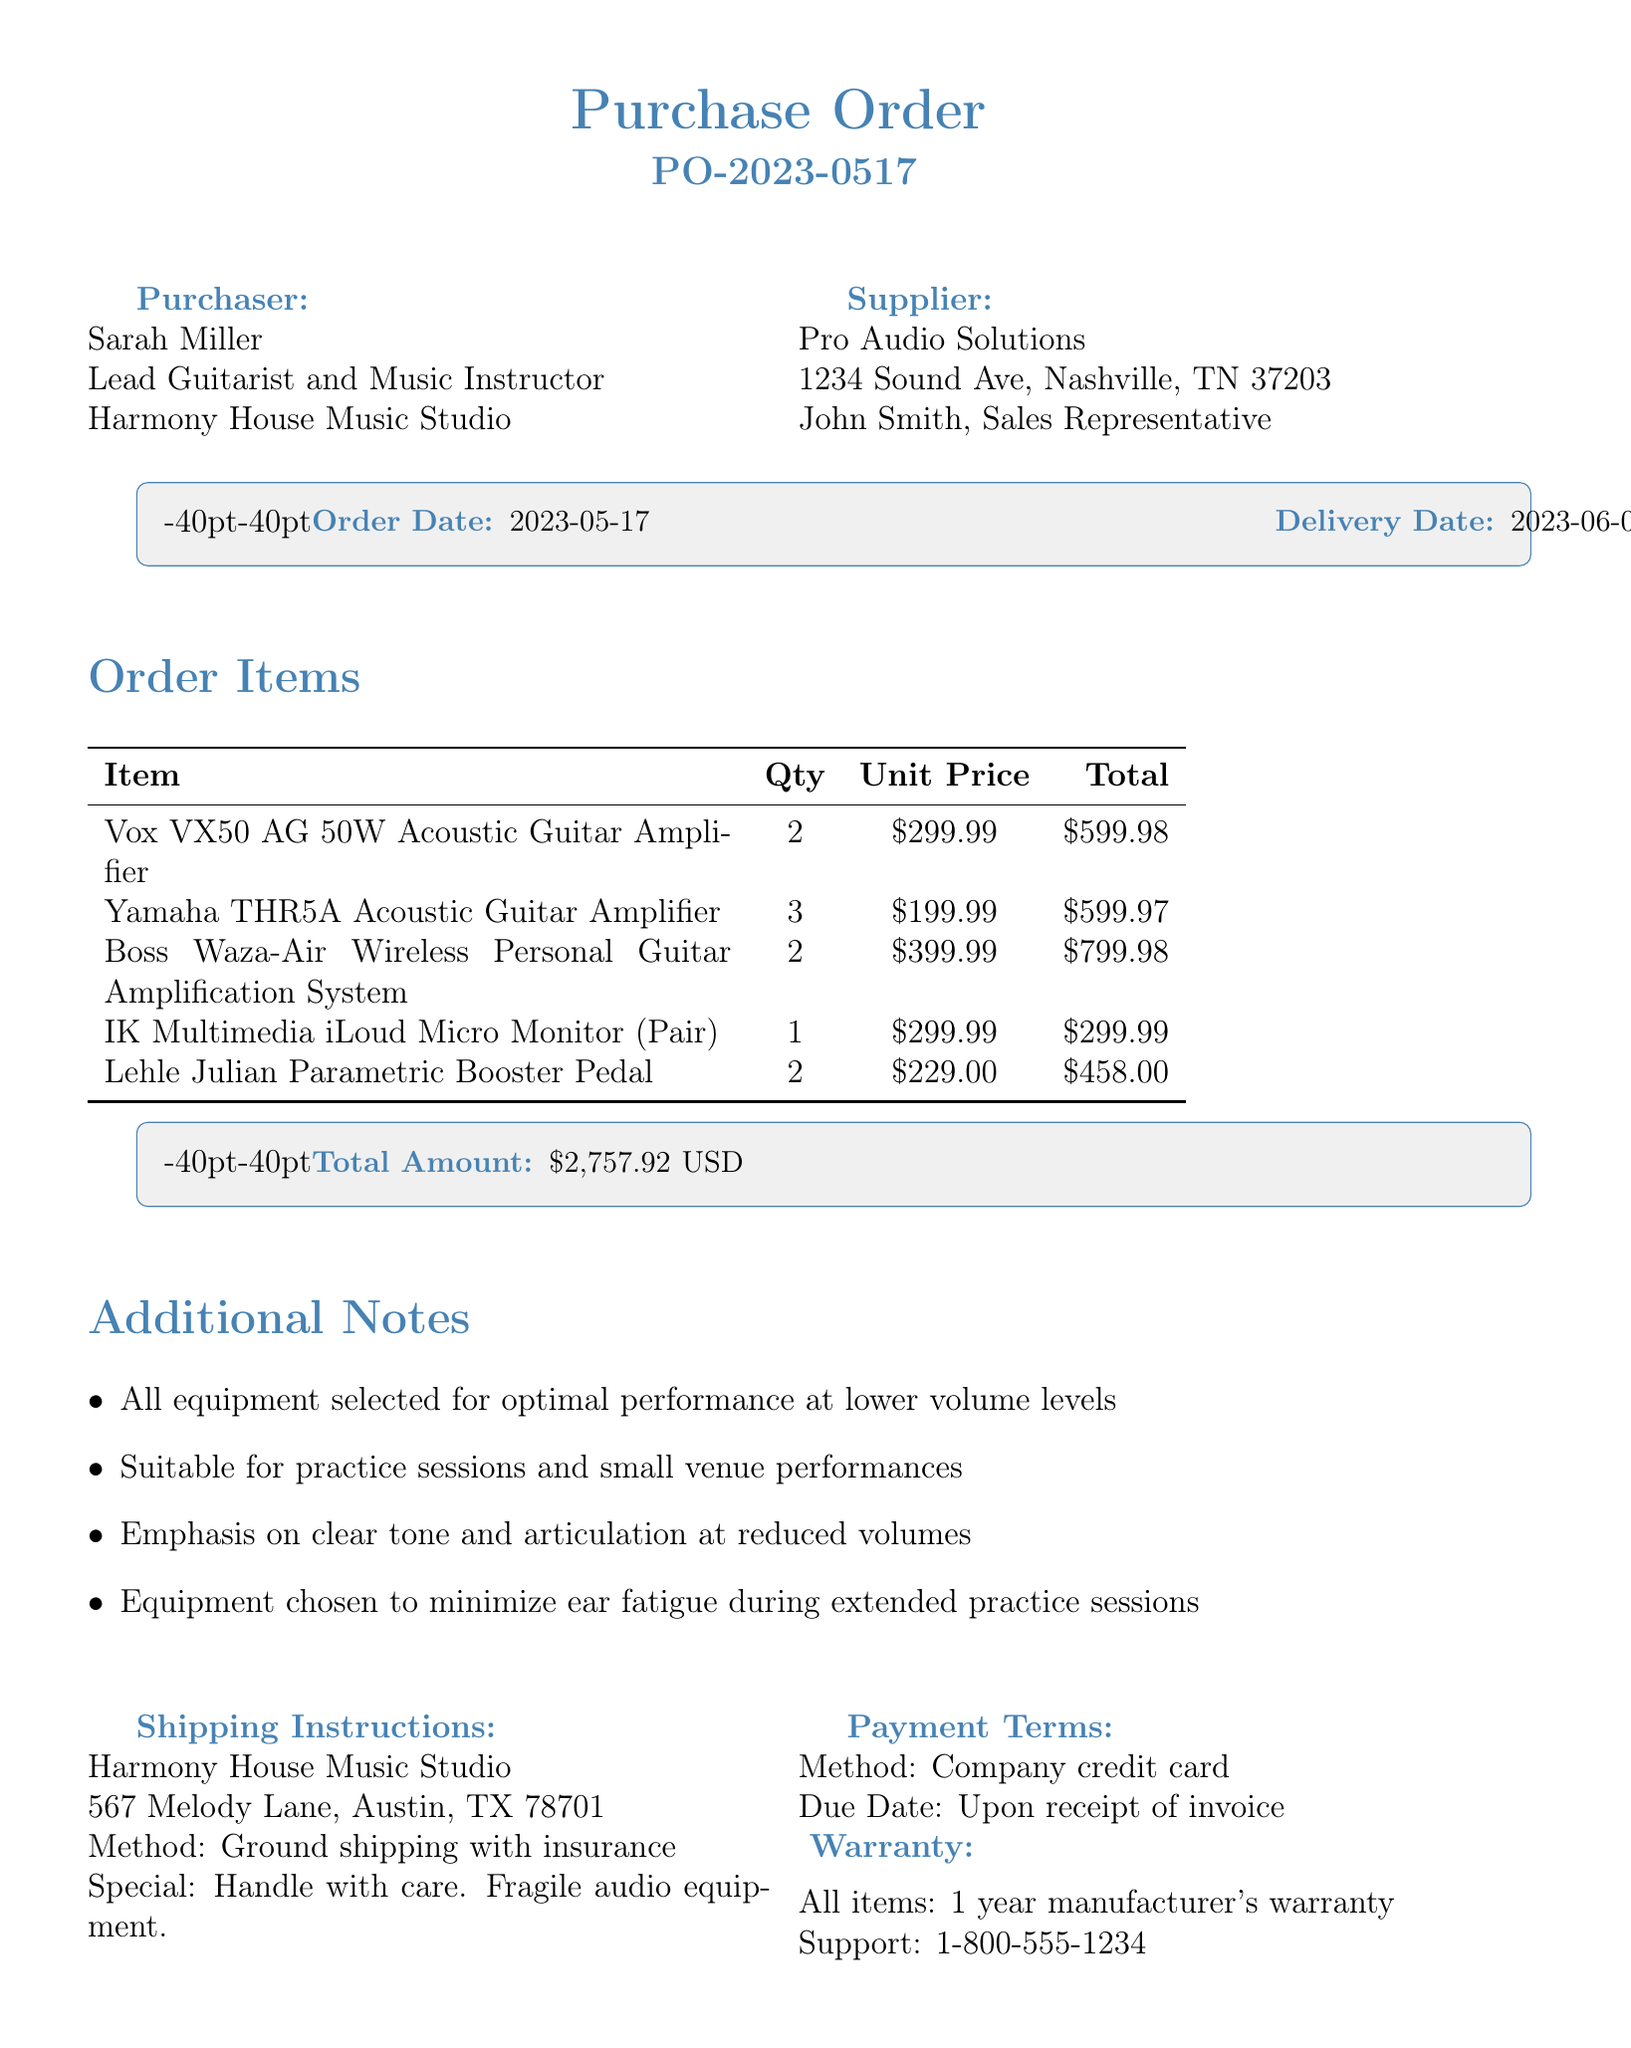What is the order number? The order number is listed prominently in the document under order details, which is PO-2023-0517.
Answer: PO-2023-0517 Who is the purchaser? The purchaser is specified in the document as Sarah Miller, along with her title and company name.
Answer: Sarah Miller What is the delivery date? The delivery date is provided in the order details section as the date when the items will be delivered.
Answer: 2023-06-01 How many Yamaha THR5A amplifiers were ordered? The quantity of Yamaha THR5A amplifiers is detailed in the items section of the document, which is 3.
Answer: 3 What is the total amount for the order? The total amount is stated at the bottom of the order items section, summing all item totals together.
Answer: 2757.92 USD What shipping method is used? The shipping method is indicated in the shipping instructions, outlining how the items will be delivered.
Answer: Ground shipping with insurance What is emphasized in the additional notes? The additional notes highlight key considerations for equipment selection in relation to volume and performance.
Answer: Optimal performance at lower volume levels What is the warranty duration for the items? The warranty information specifies how long the coverage lasts from the date of purchase.
Answer: 1 year Who should be contacted for warranty support? The document provides a specific customer service support contact for warranty-related inquiries.
Answer: 1-800-555-1234 